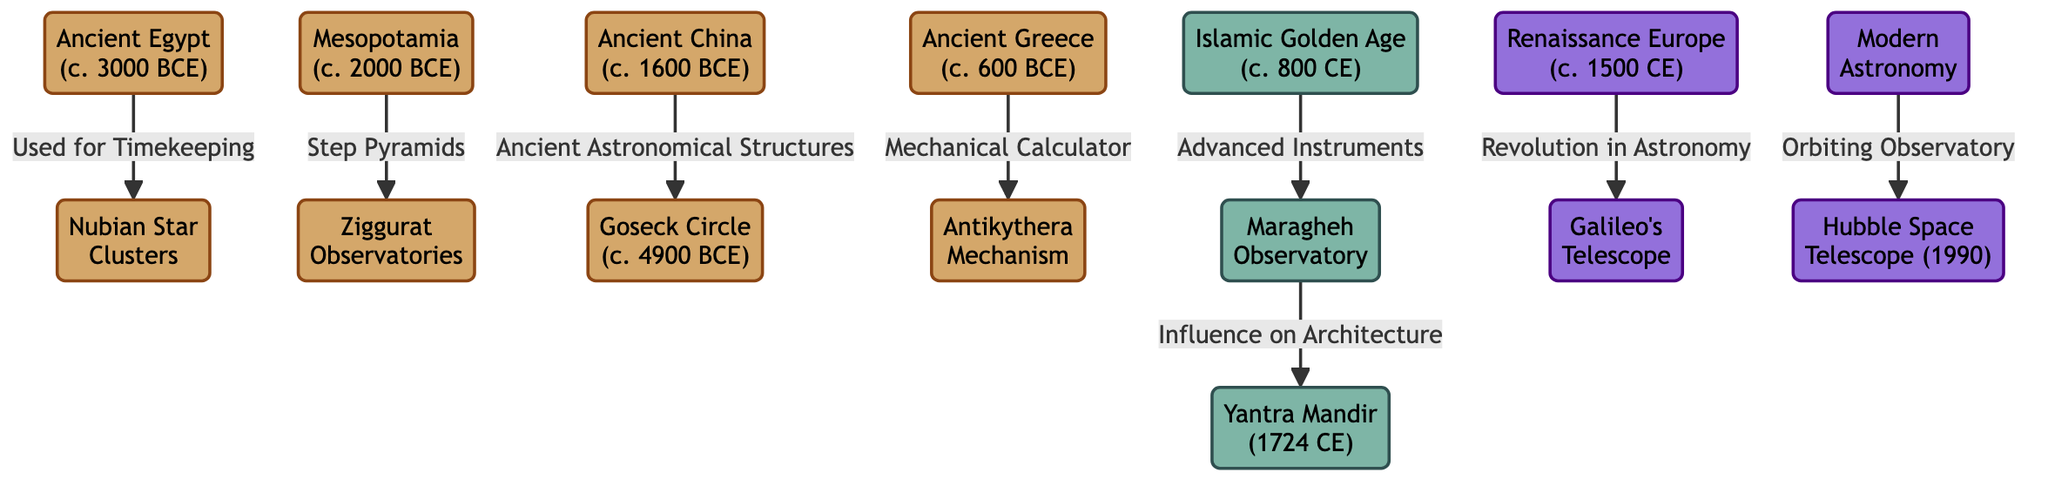What is the earliest civilization represented in the diagram? The diagram shows Ancient Egypt, with a date of around 3000 BCE, which is before all other civilizations depicted.
Answer: Ancient Egypt How many observatories are mentioned in the diagram? There are four observatories mentioned: Nubian Star Clusters, Ziggurat Observatories, Maragheh Observatory, and Yantra Mandir.
Answer: Four What type of astronomical instrument is associated with Ancient Greece? The diagram indicates that the Antikythera Mechanism is the instrument linked with Ancient Greece, as stated next to the node.
Answer: Antikythera Mechanism Which monumental structure is linked to Mesopotamia? The Ziggurat Observatories are connected to Mesopotamia, as shown by the arrow indicating their relationship in the diagram.
Answer: Ziggurat Observatories What significant event is represented in the diagram occurring around 800 CE? The Islamic Golden Age is the significant event represented, pointing to advancements in astronomical instruments during that time period.
Answer: Islamic Golden Age Name the first observatory influenced by the Islamic Golden Age. The first observatory influenced by the Islamic Golden Age, as indicated in the flow, is the Maragheh Observatory.
Answer: Maragheh Observatory What major astronomical development took place around 1500 CE? The diagram highlights the revolution in astronomy linked to Galileo's Telescope occurring around 1500 CE.
Answer: Galileo's Telescope How are the Hubble Space Telescope and modern astronomy connected in the diagram? The Hubble Space Telescope is positioned as a further development in the flow from modern astronomy, representing an advanced observational tool in space.
Answer: Orbiting Observatory What ancient structure is indicated to be from ancient China? The Goseck Circle is the ancient astronomical structure indicated for ancient China, as per its placement in the diagram.
Answer: Goseck Circle 